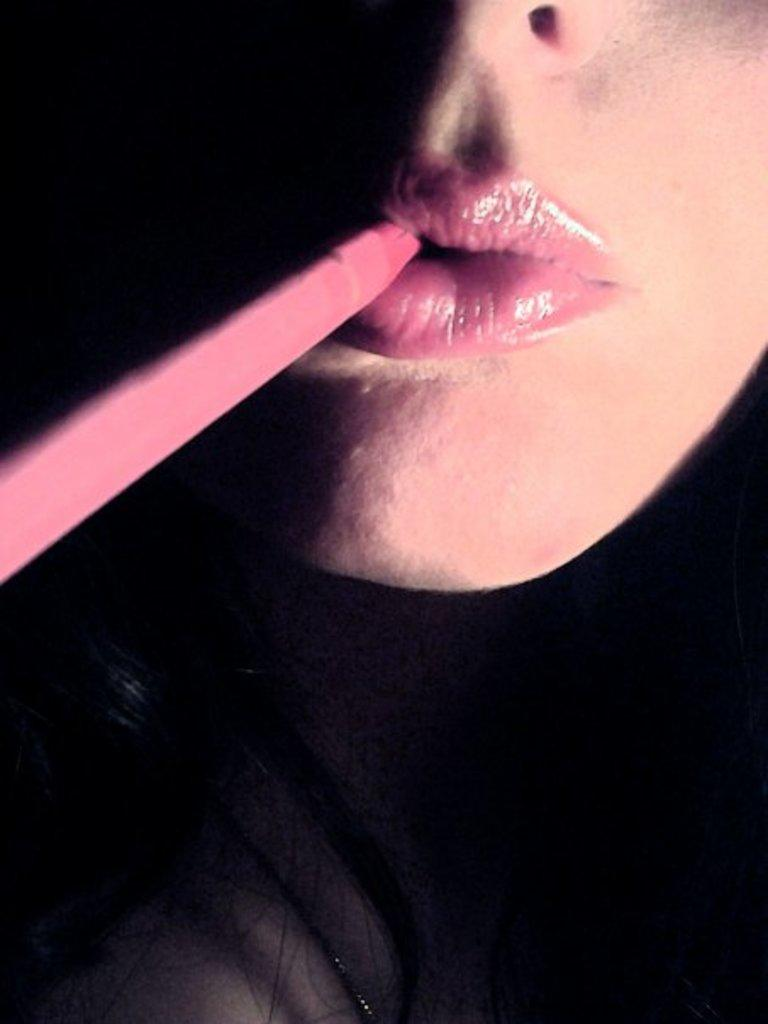What is the main subject of the image? There is a person in the image. Can you describe the object on the left side of the image? Unfortunately, the facts provided do not give any details about the object on the left side of the image. However, we can confirm that there is an object present. How much attention is the person paying to the wood and dust in the image? There is no wood or dust present in the image, so it is not possible to determine how much attention the person is paying to them. 